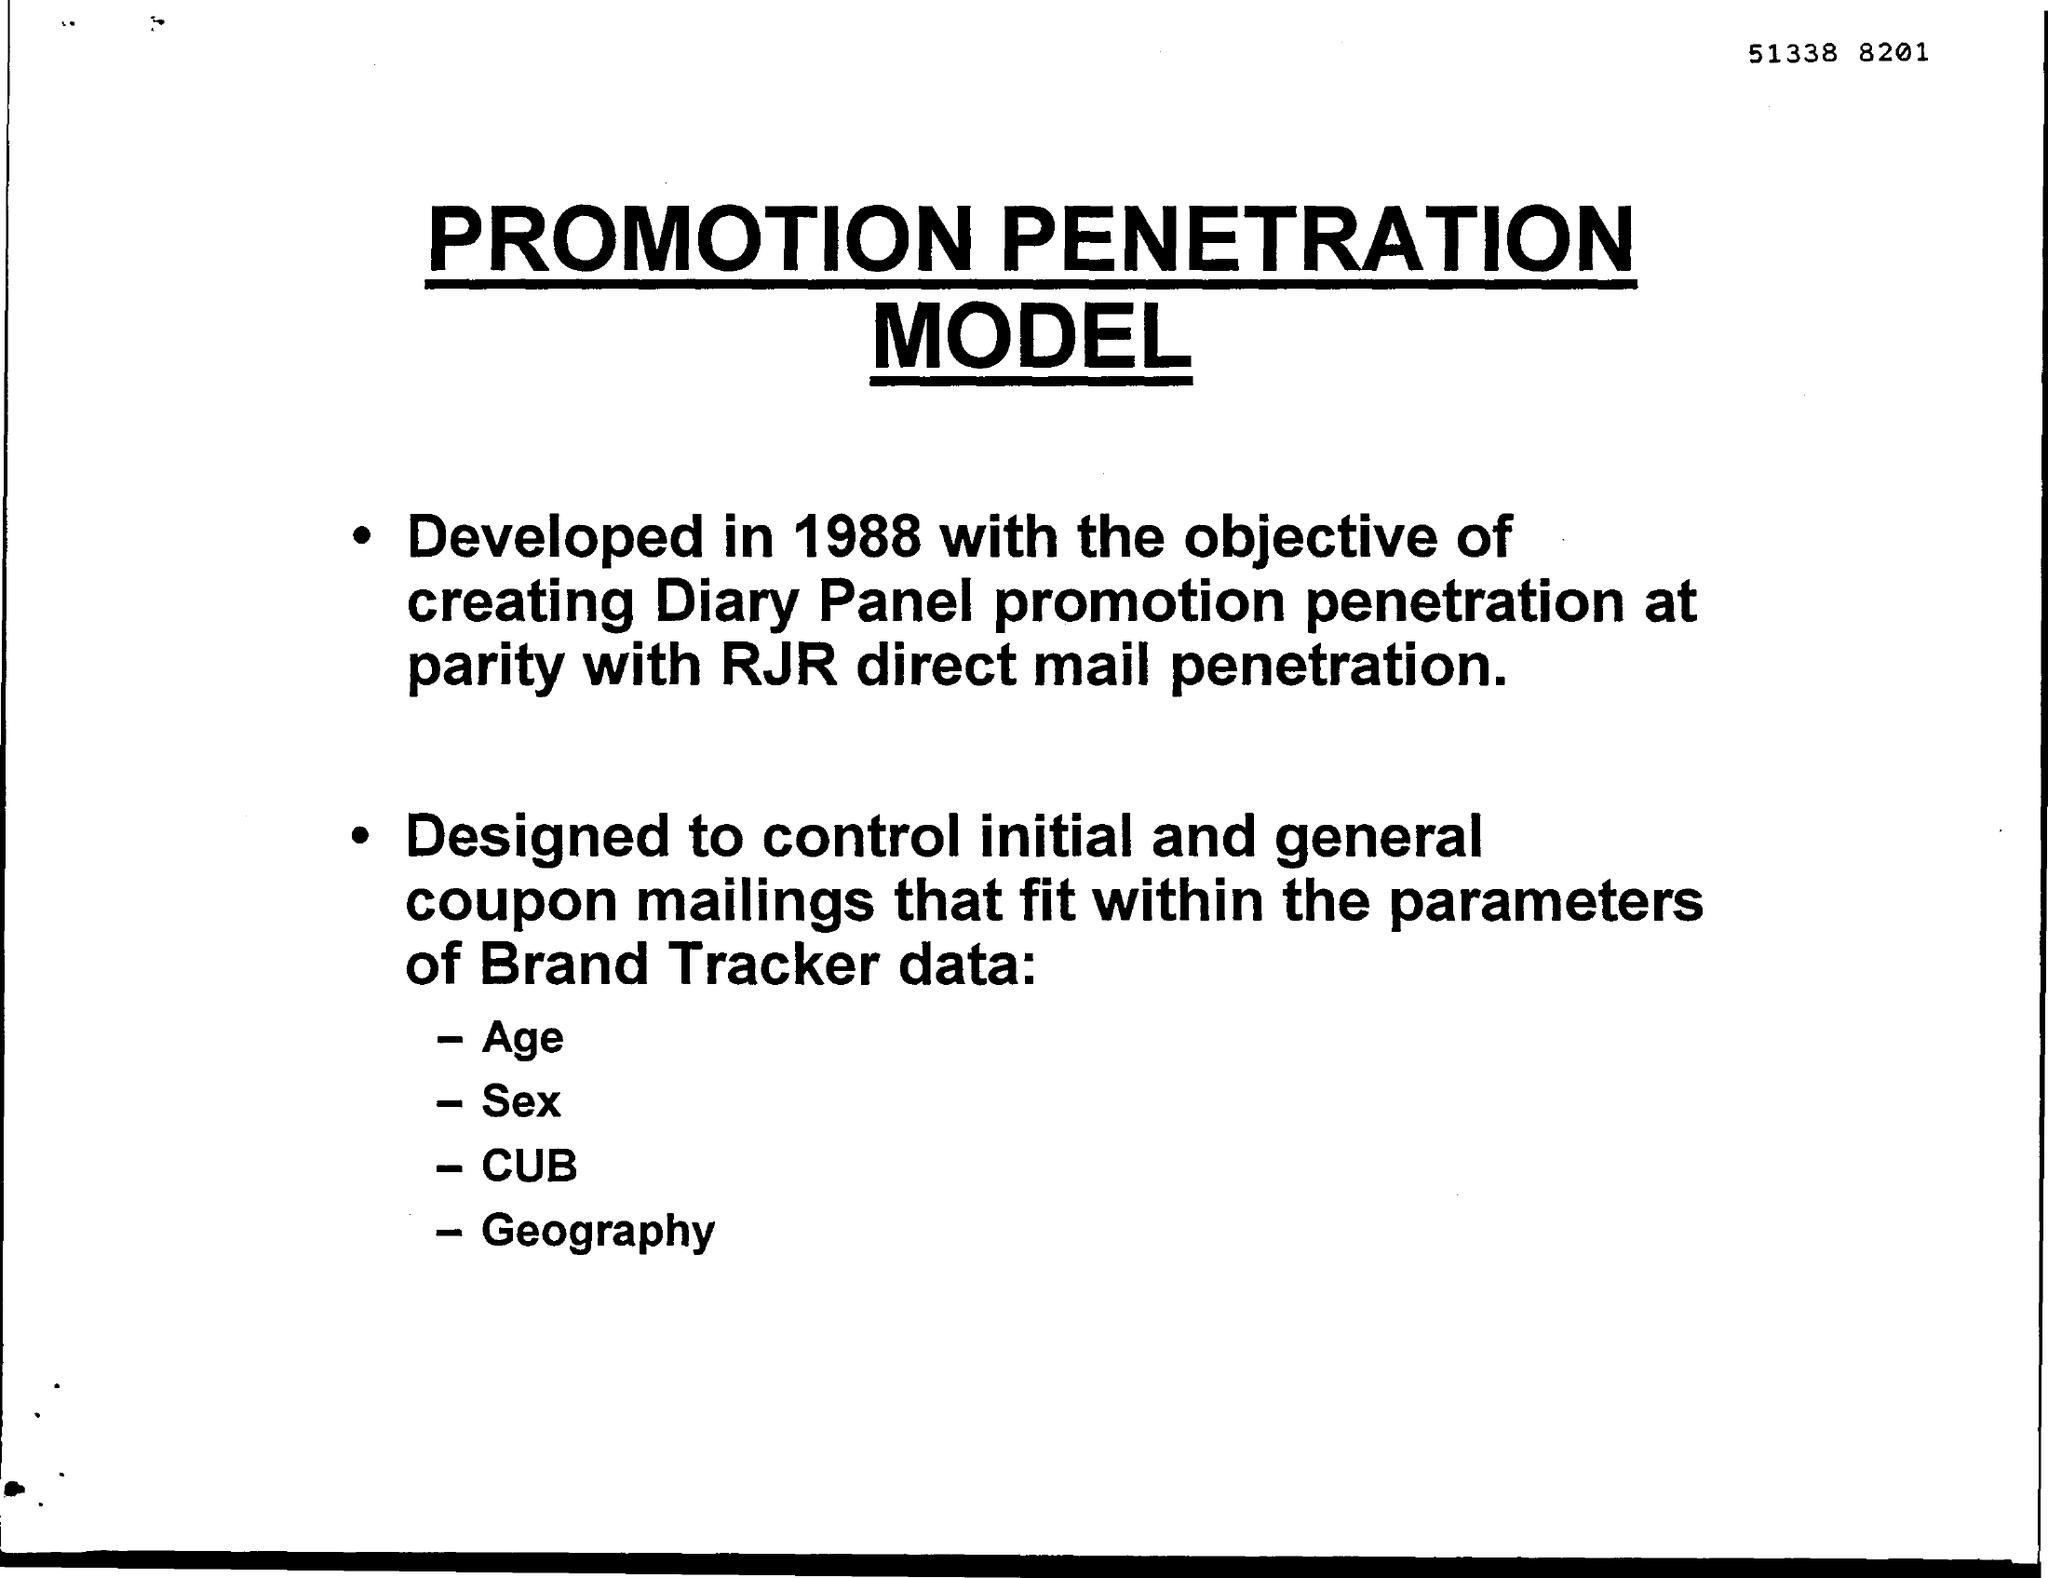Point out several critical features in this image. The document title is 'PROMOTION PENETRATION MODEL.' The model was developed in the year 1988. 